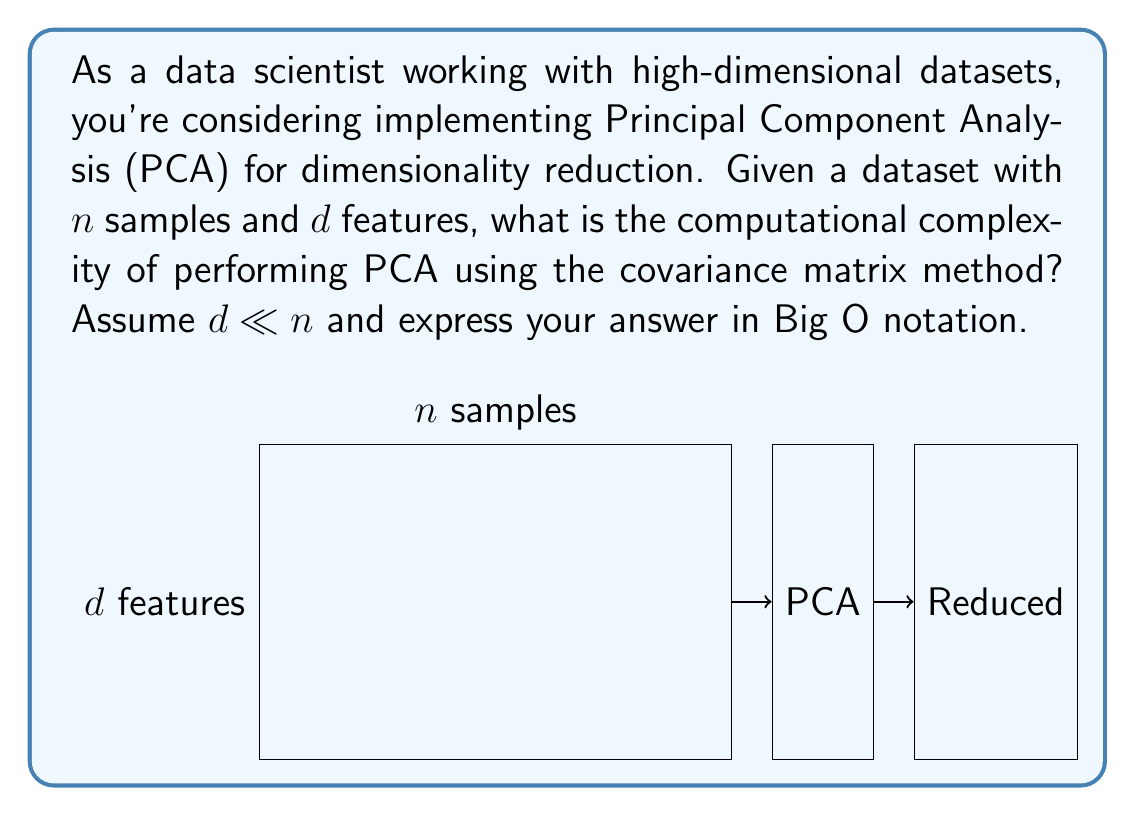What is the answer to this math problem? To determine the computational complexity of PCA using the covariance matrix method, we need to break down the process into steps:

1. Compute the mean vector:
   - Complexity: $O(nd)$

2. Center the data by subtracting the mean:
   - Complexity: $O(nd)$

3. Compute the covariance matrix:
   - Complexity: $O(nd^2)$
   This step involves matrix multiplication of the centered data matrix $(n \times d)$ with its transpose $(d \times n)$.

4. Compute the eigenvalues and eigenvectors of the covariance matrix:
   - Complexity: $O(d^3)$
   This is typically done using algorithms like QR decomposition.

5. Sort eigenvalues and corresponding eigenvectors:
   - Complexity: $O(d \log d)$

6. Select top $k$ eigenvectors (where $k \leq d$):
   - Complexity: $O(k)$, which is bounded by $O(d)$

7. Project the data onto the new subspace:
   - Complexity: $O(ndk)$, which is bounded by $O(nd^2)$

The overall complexity is dominated by the most expensive steps: computing the covariance matrix $O(nd^2)$ and eigendecomposition $O(d^3)$.

Since we're given that $d \ll n$, we can conclude that $O(nd^2)$ is the dominant term.

Therefore, the overall computational complexity of PCA using the covariance matrix method is $O(nd^2)$.
Answer: $O(nd^2)$ 